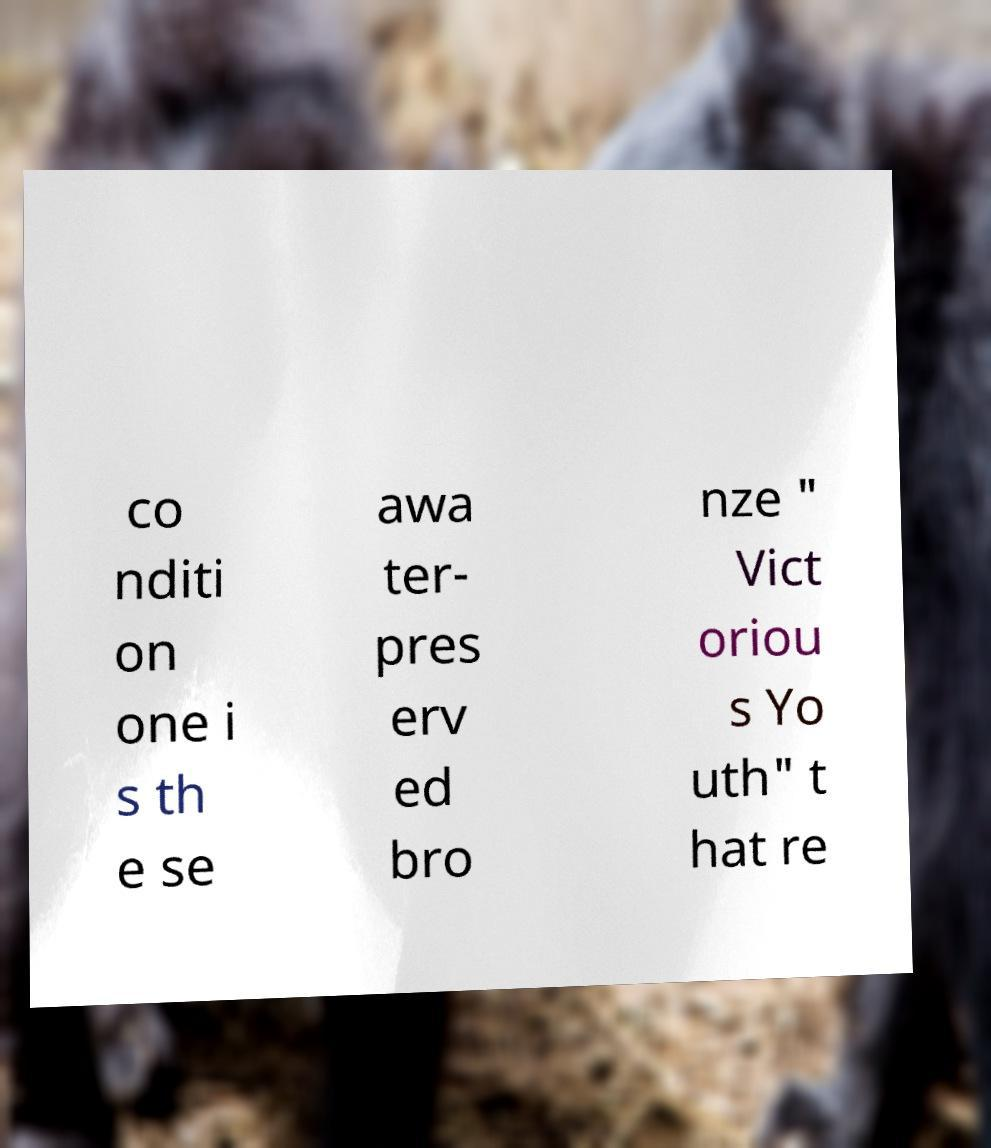What messages or text are displayed in this image? I need them in a readable, typed format. co nditi on one i s th e se awa ter- pres erv ed bro nze " Vict oriou s Yo uth" t hat re 